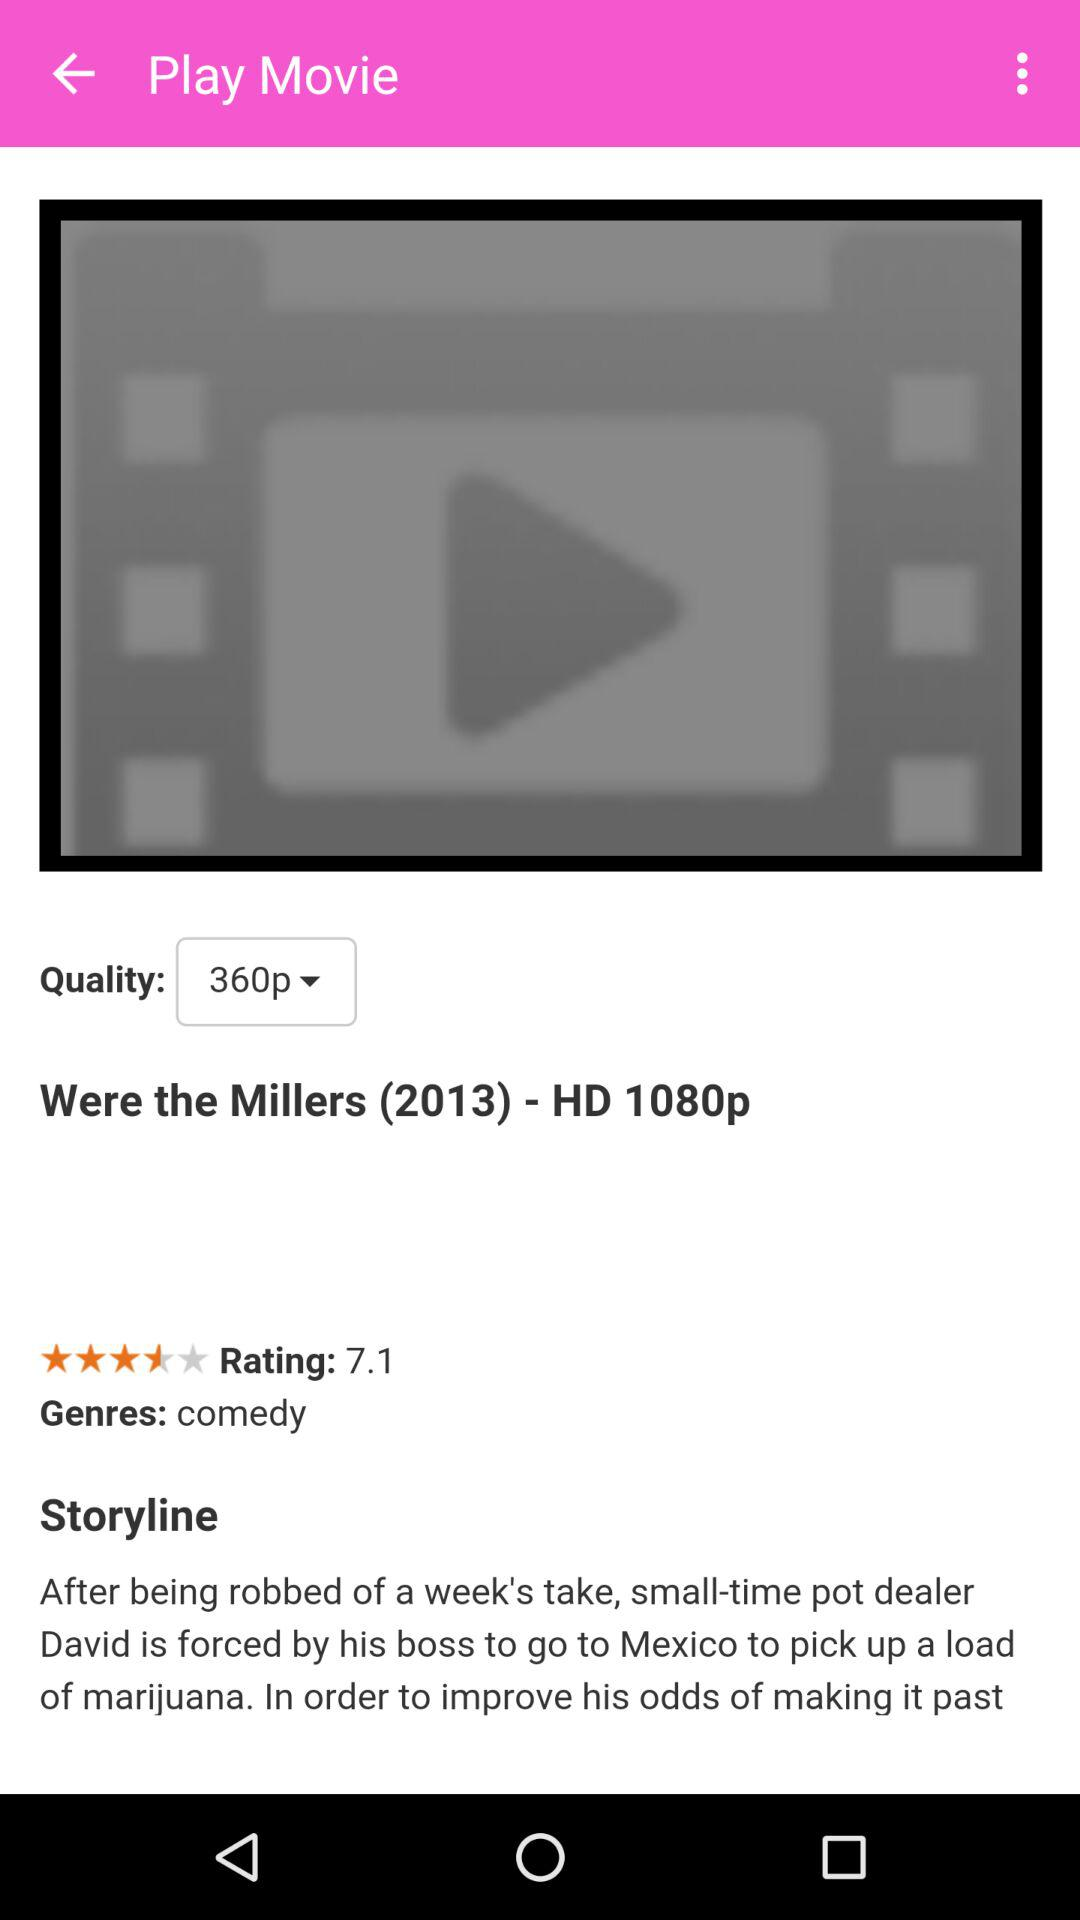Which quality of the movie is selected? The selected quality of the movie is 360p. 